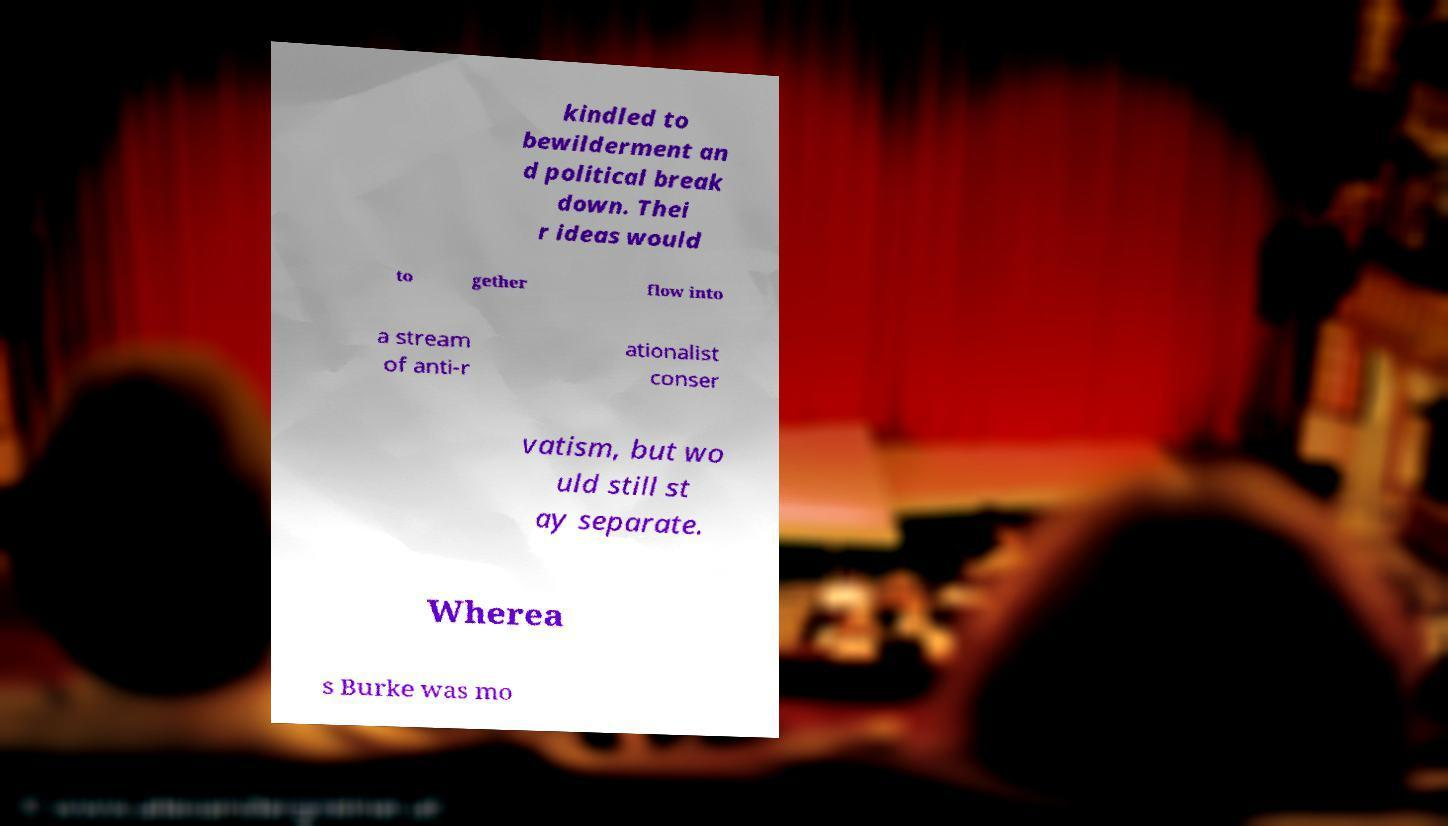Could you assist in decoding the text presented in this image and type it out clearly? kindled to bewilderment an d political break down. Thei r ideas would to gether flow into a stream of anti-r ationalist conser vatism, but wo uld still st ay separate. Wherea s Burke was mo 